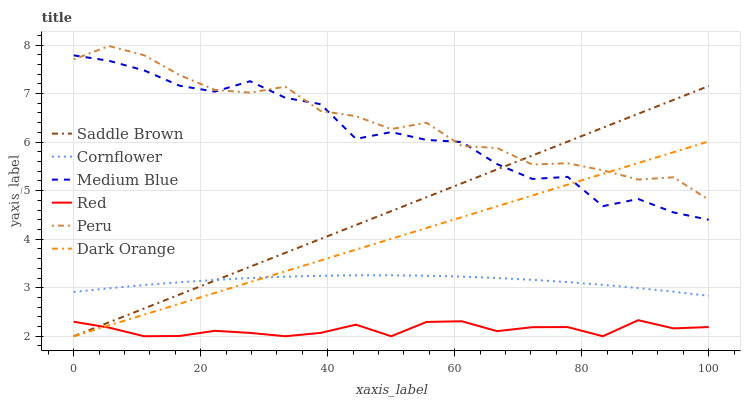Does Red have the minimum area under the curve?
Answer yes or no. Yes. Does Peru have the maximum area under the curve?
Answer yes or no. Yes. Does Dark Orange have the minimum area under the curve?
Answer yes or no. No. Does Dark Orange have the maximum area under the curve?
Answer yes or no. No. Is Saddle Brown the smoothest?
Answer yes or no. Yes. Is Medium Blue the roughest?
Answer yes or no. Yes. Is Dark Orange the smoothest?
Answer yes or no. No. Is Dark Orange the roughest?
Answer yes or no. No. Does Medium Blue have the lowest value?
Answer yes or no. No. Does Dark Orange have the highest value?
Answer yes or no. No. Is Cornflower less than Medium Blue?
Answer yes or no. Yes. Is Cornflower greater than Red?
Answer yes or no. Yes. Does Cornflower intersect Medium Blue?
Answer yes or no. No. 